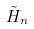Convert formula to latex. <formula><loc_0><loc_0><loc_500><loc_500>\tilde { H } _ { n }</formula> 